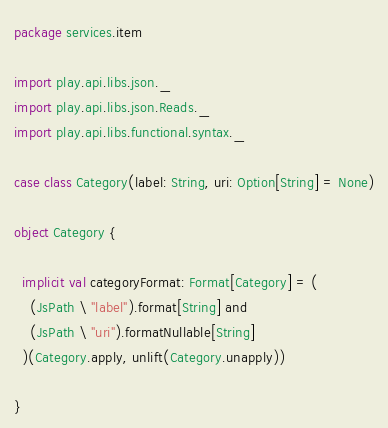Convert code to text. <code><loc_0><loc_0><loc_500><loc_500><_Scala_>package services.item

import play.api.libs.json._
import play.api.libs.json.Reads._
import play.api.libs.functional.syntax._

case class Category(label: String, uri: Option[String] = None)

object Category {
 
  implicit val categoryFormat: Format[Category] = (
    (JsPath \ "label").format[String] and
    (JsPath \ "uri").formatNullable[String]
  )(Category.apply, unlift(Category.unapply))
  
}</code> 